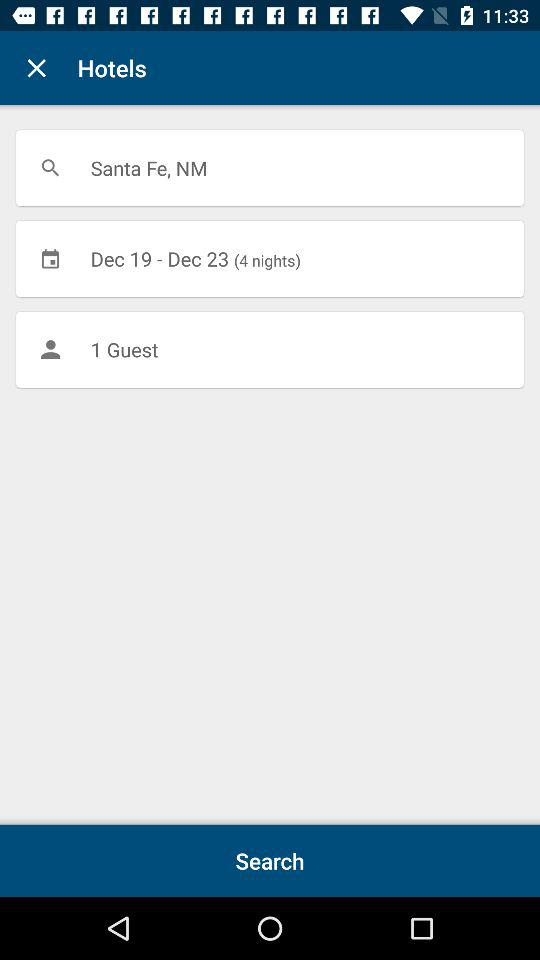How many more nights are there than guests?
Answer the question using a single word or phrase. 3 